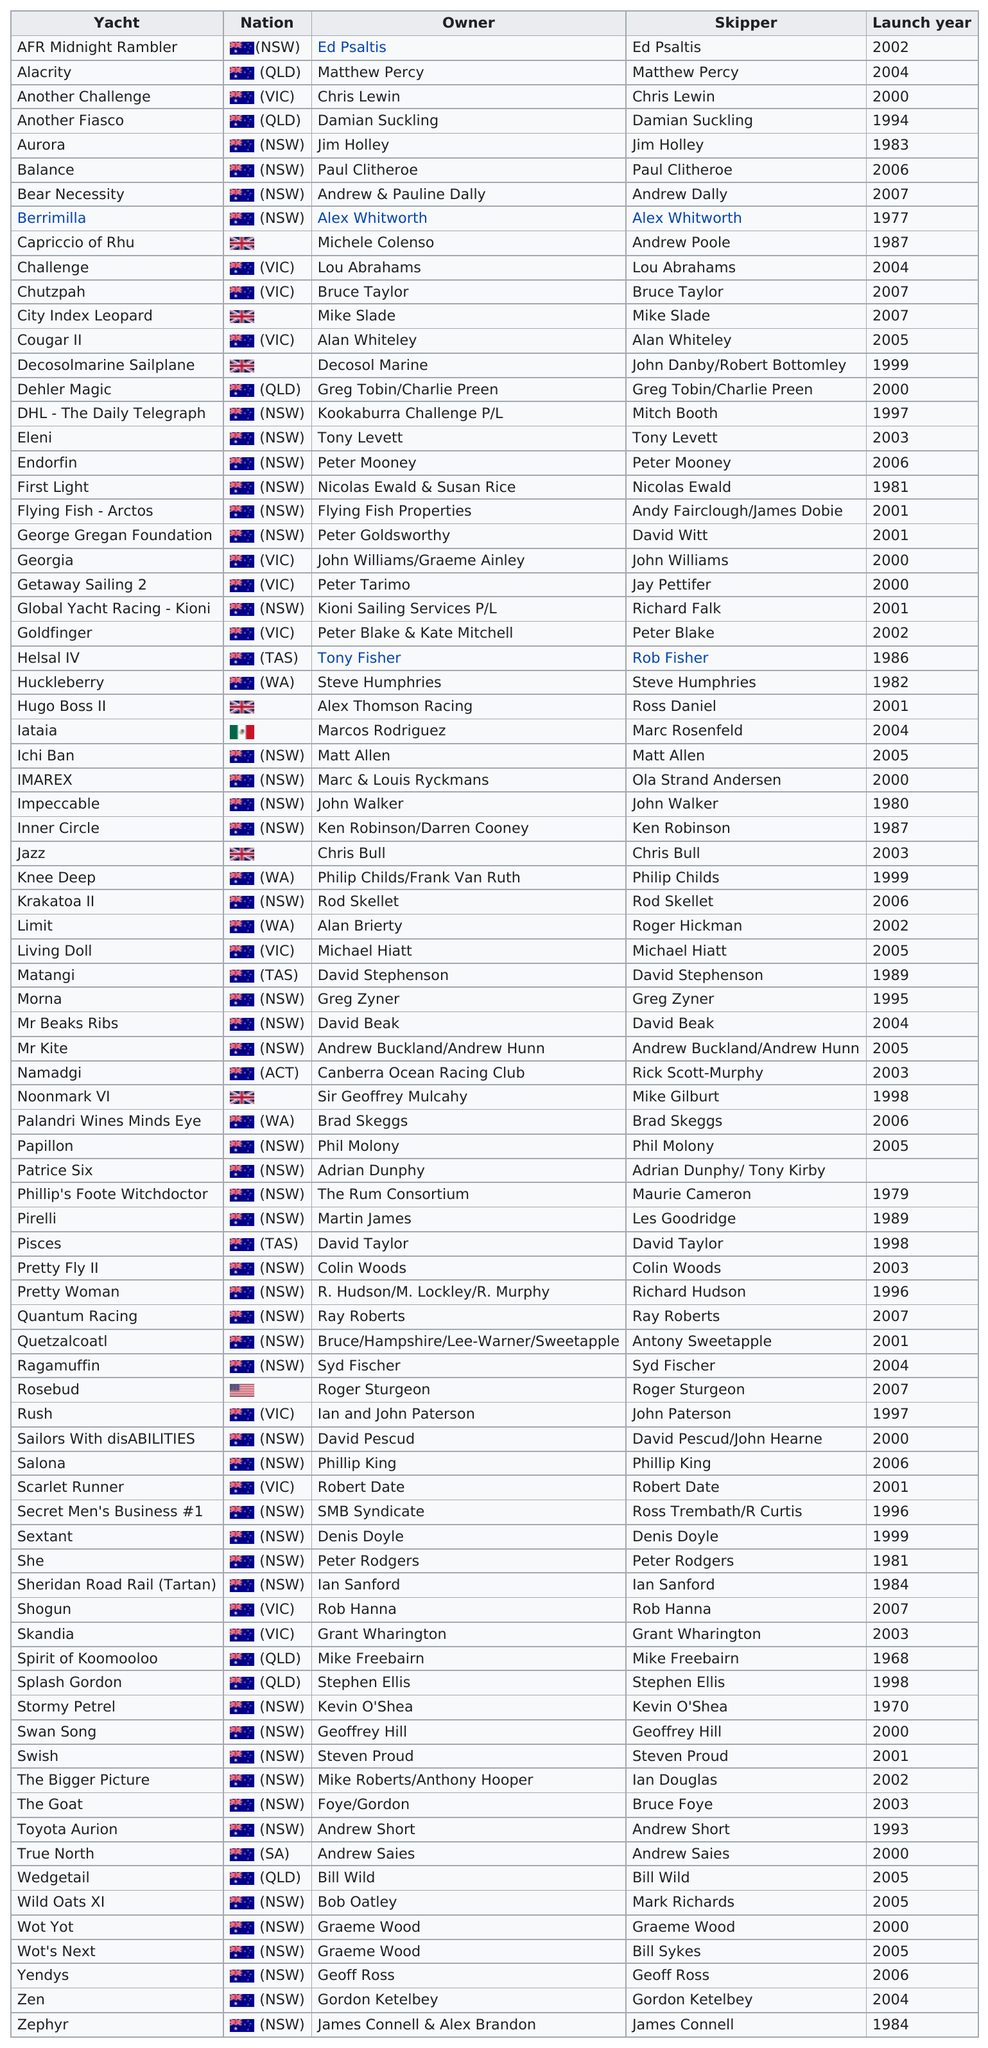Identify some key points in this picture. In 2000, nine yachts were launched. Other than Rosebud, a yacht originating from a country other than Australia and Great Britain also exists. James Connell is the last skipper of yachts. In 2001, a total of 7 yachts were launched. There are a total of 82 yachts on the list. 